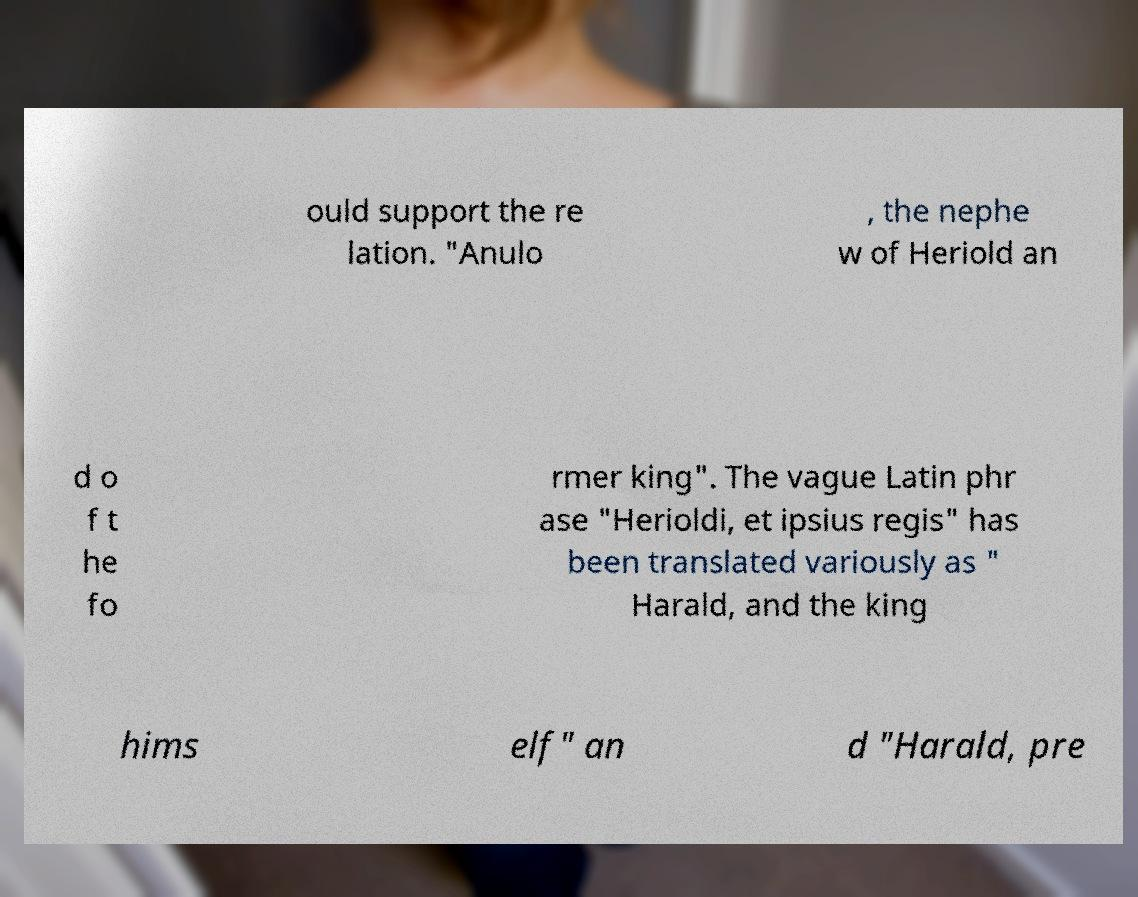Could you extract and type out the text from this image? ould support the re lation. "Anulo , the nephe w of Heriold an d o f t he fo rmer king". The vague Latin phr ase "Herioldi, et ipsius regis" has been translated variously as " Harald, and the king hims elf" an d "Harald, pre 